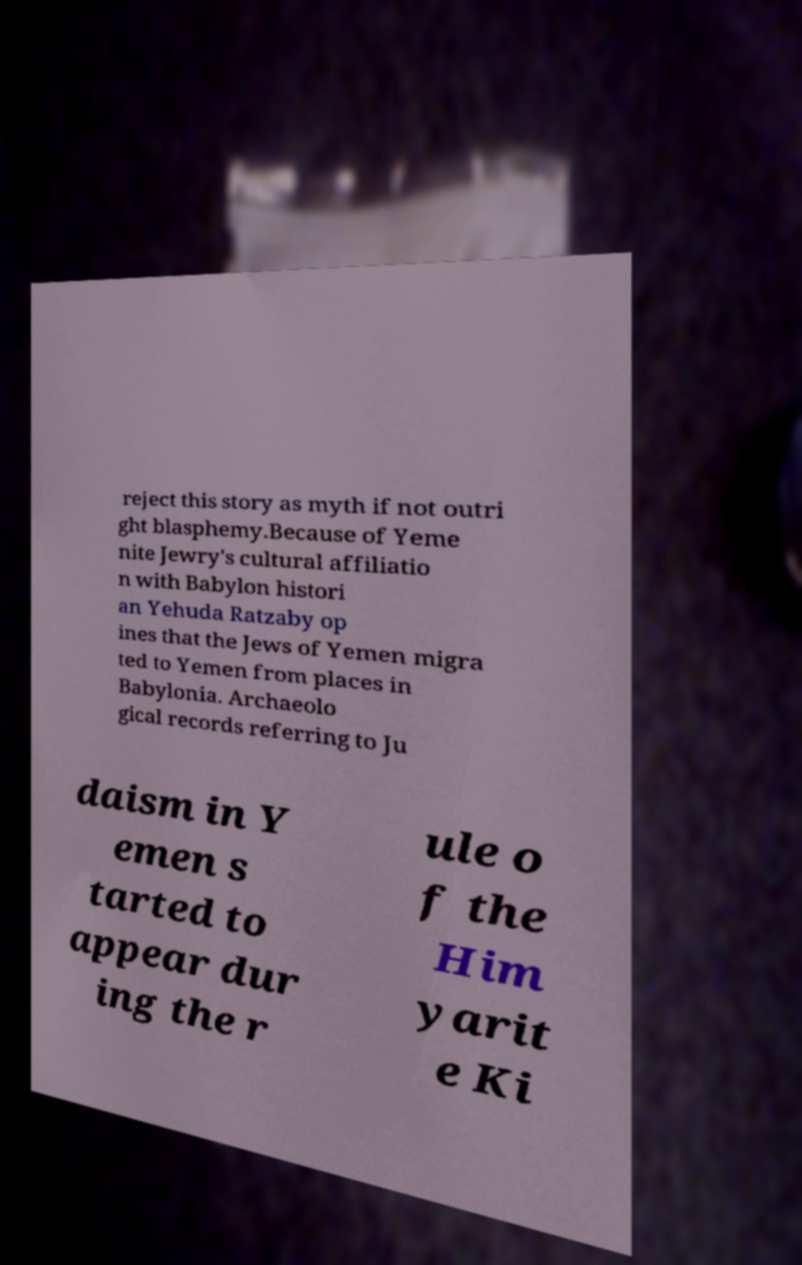Can you read and provide the text displayed in the image?This photo seems to have some interesting text. Can you extract and type it out for me? reject this story as myth if not outri ght blasphemy.Because of Yeme nite Jewry's cultural affiliatio n with Babylon histori an Yehuda Ratzaby op ines that the Jews of Yemen migra ted to Yemen from places in Babylonia. Archaeolo gical records referring to Ju daism in Y emen s tarted to appear dur ing the r ule o f the Him yarit e Ki 